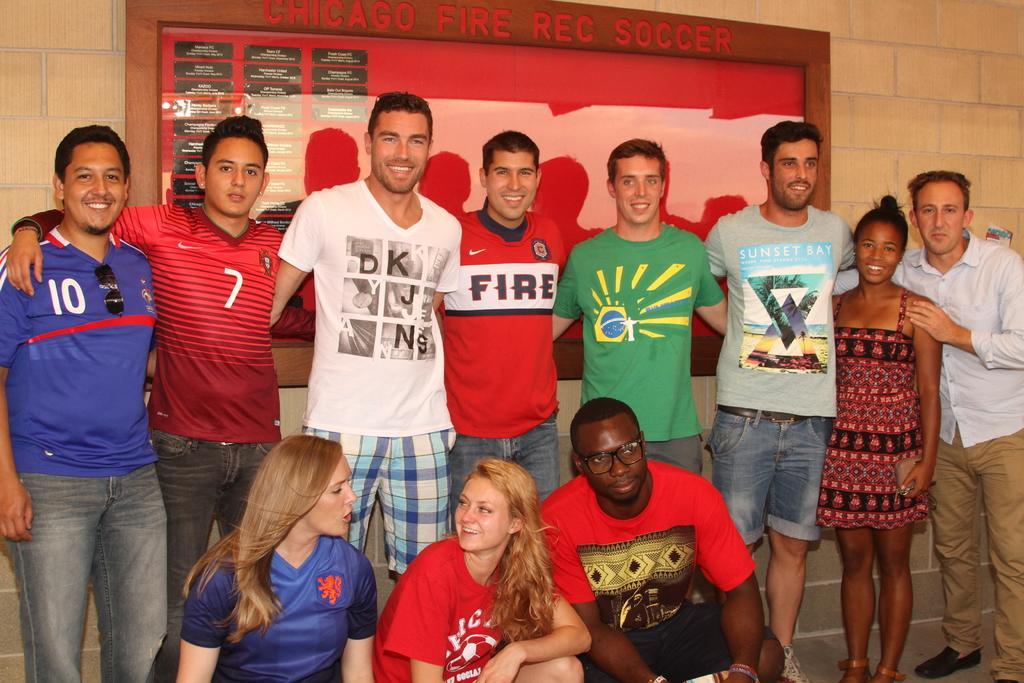Could you give a brief overview of what you see in this image? In this picture there are group of people those who are standing in the center of the image and there is a poster in the background area of the image. 